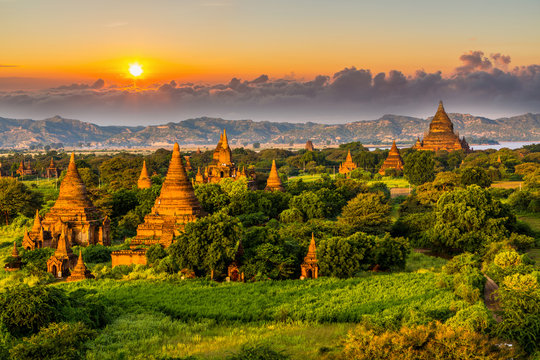What kind of flora can be observed in this area, surrounding the temples? The area around Bagan is lush with a variety of flora, predominantly comprised of deciduous trees and shrubs which thrive in the dry tropical climate. Moreover, during the rainy season, the landscape is enriched with vibrant greenery and occasional bursts of wildflowers, adding a lively contrast to the earthy tones of the ancient temples. Are these natural features part of the conservation efforts for the site? Yes, the natural features around Bagan are an integral part of conservation efforts. Preserving the native vegetation not only supports the local ecosystem but also helps protect the soil and foundations of these ancient structures from erosion and other natural wear, ensuring that both the natural and cultural heritage can be sustained for future generations. 